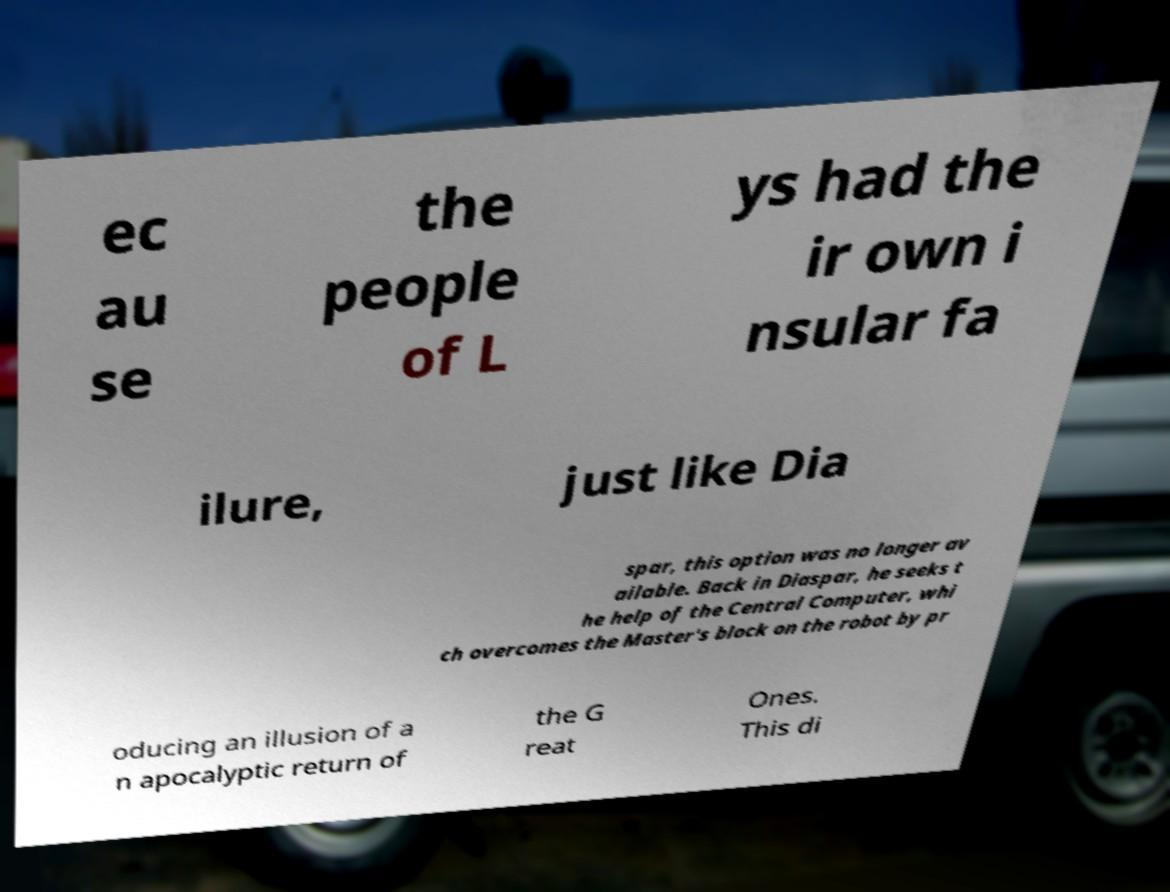Could you assist in decoding the text presented in this image and type it out clearly? ec au se the people of L ys had the ir own i nsular fa ilure, just like Dia spar, this option was no longer av ailable. Back in Diaspar, he seeks t he help of the Central Computer, whi ch overcomes the Master's block on the robot by pr oducing an illusion of a n apocalyptic return of the G reat Ones. This di 